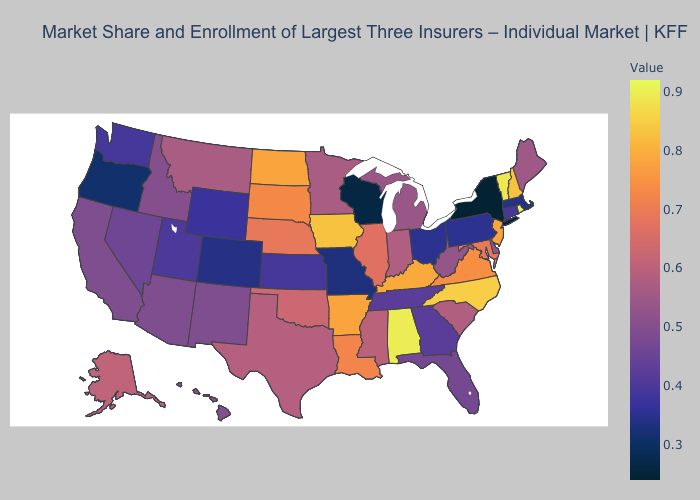Does Wyoming have a higher value than Wisconsin?
Quick response, please. Yes. Does Alaska have the highest value in the West?
Give a very brief answer. Yes. Among the states that border North Dakota , does Minnesota have the highest value?
Be succinct. No. Does Tennessee have the lowest value in the South?
Be succinct. Yes. Which states have the lowest value in the MidWest?
Write a very short answer. Wisconsin. Does North Dakota have the highest value in the MidWest?
Be succinct. No. Among the states that border Maryland , which have the lowest value?
Quick response, please. Pennsylvania. 